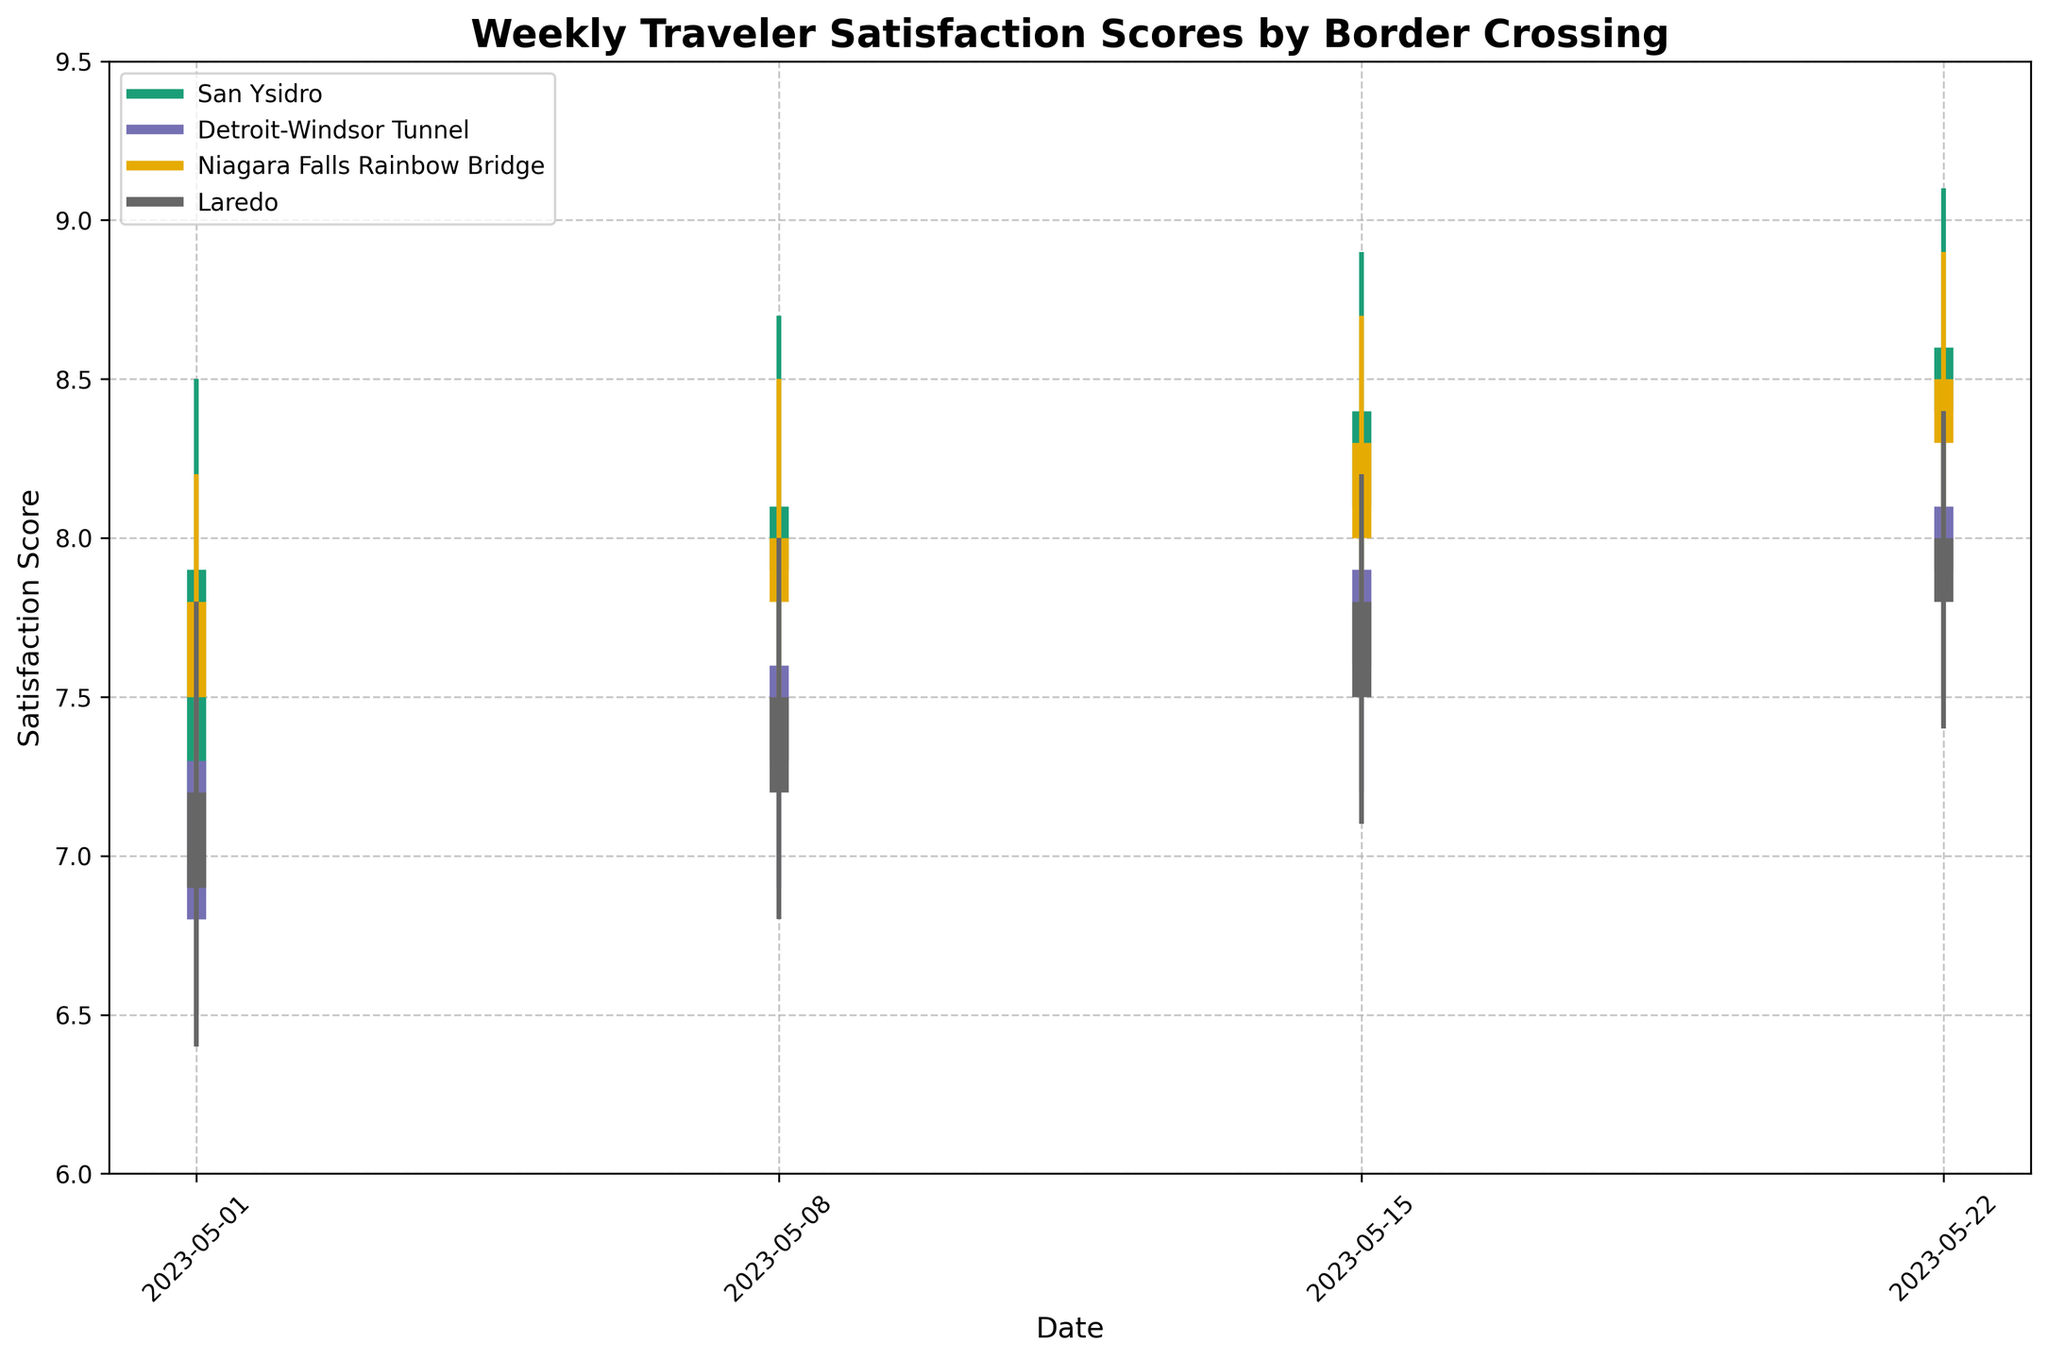what is the title of the figure? The title is located at the top of the chart and is styled in a bold font. It gives a brief description of what the chart represents. Here, the title reads "Weekly Traveler Satisfaction Scores by Border Crossing".
Answer: Weekly Traveler Satisfaction Scores by Border Crossing What is the range of satisfaction scores on the y-axis? The y-axis shows the range of satisfaction scores. By looking at the axis labels, we can see it ranges from 6 to 9.5.
Answer: 6 to 9.5 Which border crossing point showed the highest satisfaction score in the given timeframe? To find this, we need to look at the peaks represented by the high values. San Ysidro reached a high of 9.1 on May 22, which is the highest score in the dataset.
Answer: San Ysidro Did San Ysidro's satisfaction score ever drop below 7.0 within the specified dates? Referring to the low values for San Ysidro on the chart, the lowest score is 6.8 on May 1st.
Answer: Yes Which border crossing had the smallest range in their satisfaction scores for the week of May 08? Look at the high and low values for the week of May 08 for all crossings. San Ysidro has a low of 7.3 and a high of 8.7, making the range 1.4. The smallest range actually belongs to Niagara Falls Rainbow Bridge, with a high of 8.5 and a low of 7.4, making the range 1.1.
Answer: Niagara Falls Rainbow Bridge Which border crossing had a consistent rise in their closing satisfaction scores across all weeks? By tracing the closing scores over each week for all crossings, we see that San Ysidro’s closing scores consistently rise from 7.9, to 8.1, then 8.4, and finally to 8.6.
Answer: San Ysidro How many weeks did Detroit-Windsor Tunnel have a closing satisfaction score above 8.0? Checking the Detroit-Windsor Tunnel’s closing scores for each week, we see that it only closes above 8.0 on May 22 with a score of 8.1.
Answer: 1 What was the average opening satisfaction score for Niagara Falls Rainbow Bridge in May 2023? To find this, add up the opening scores for each week for this border, then divide by the number of weeks: (7.5 + 7.8 + 8.0 + 8.3)/4 = 31.6/4 = 7.9.
Answer: 7.9 Comparing May 15 and May 22, which border crossing saw the highest increase in their closing satisfaction score? Calculate the difference in closing scores between these two dates for all crossings. San Ysidro increased from 8.4 to 8.6 (+0.2), Detroit-Windsor Tunnel from 7.9 to 8.1 (+0.2), Niagara Falls Rainbow Bridge from 8.3 to 8.5 (+0.2), and Laredo from 7.8 to 8.0 (+0.2). Since the increase for all crossings is the same, they all tied.
Answer: All tied 